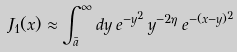Convert formula to latex. <formula><loc_0><loc_0><loc_500><loc_500>J _ { 1 } ( x ) \approx \int _ { \bar { a } } ^ { \infty } d y \, e ^ { - y ^ { 2 } } \, y ^ { - 2 \eta } \, e ^ { - ( x - y ) ^ { 2 } }</formula> 